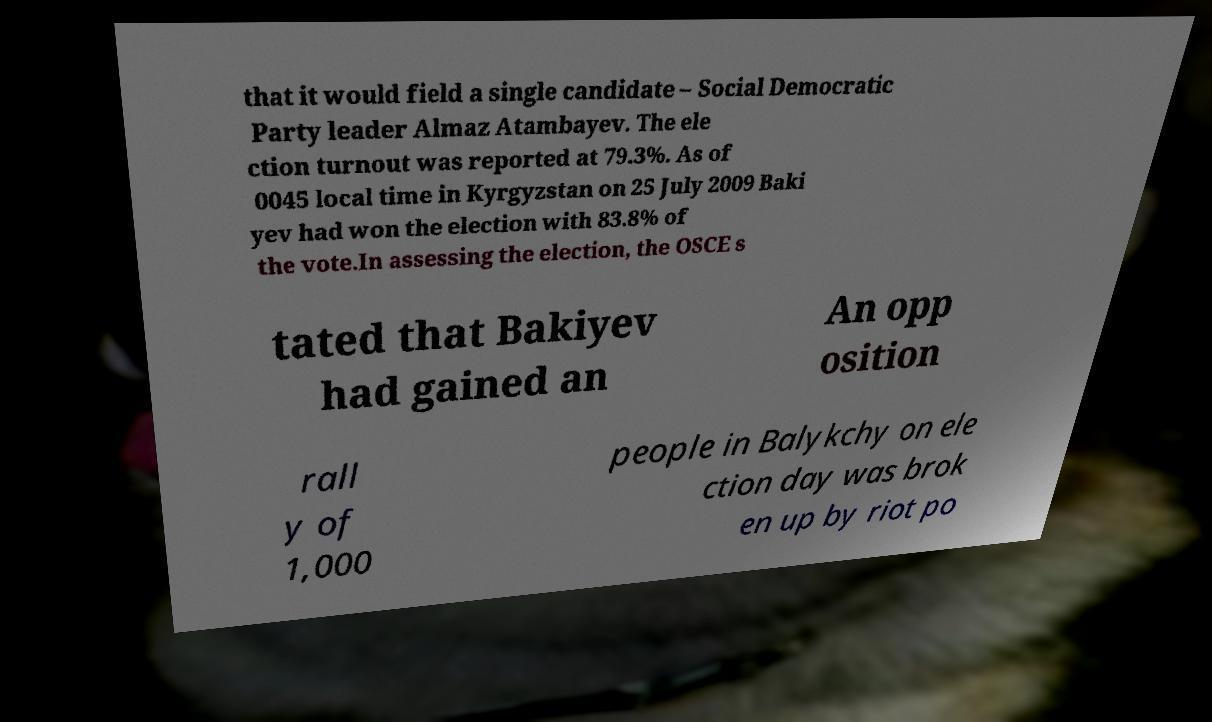I need the written content from this picture converted into text. Can you do that? that it would field a single candidate – Social Democratic Party leader Almaz Atambayev. The ele ction turnout was reported at 79.3%. As of 0045 local time in Kyrgyzstan on 25 July 2009 Baki yev had won the election with 83.8% of the vote.In assessing the election, the OSCE s tated that Bakiyev had gained an An opp osition rall y of 1,000 people in Balykchy on ele ction day was brok en up by riot po 